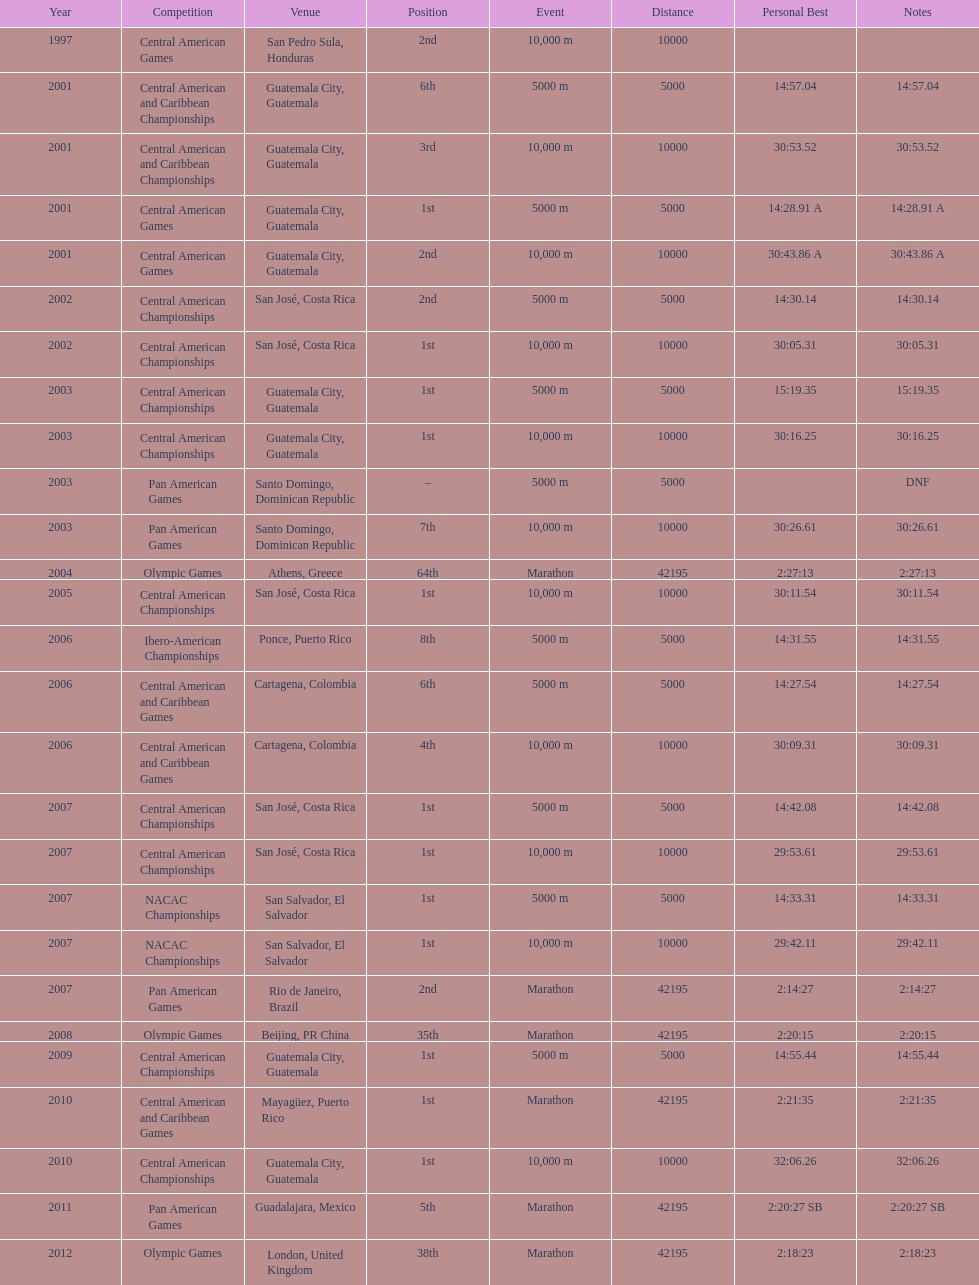What competition did this competitor compete at after participating in the central american games in 2001? Central American Championships. 